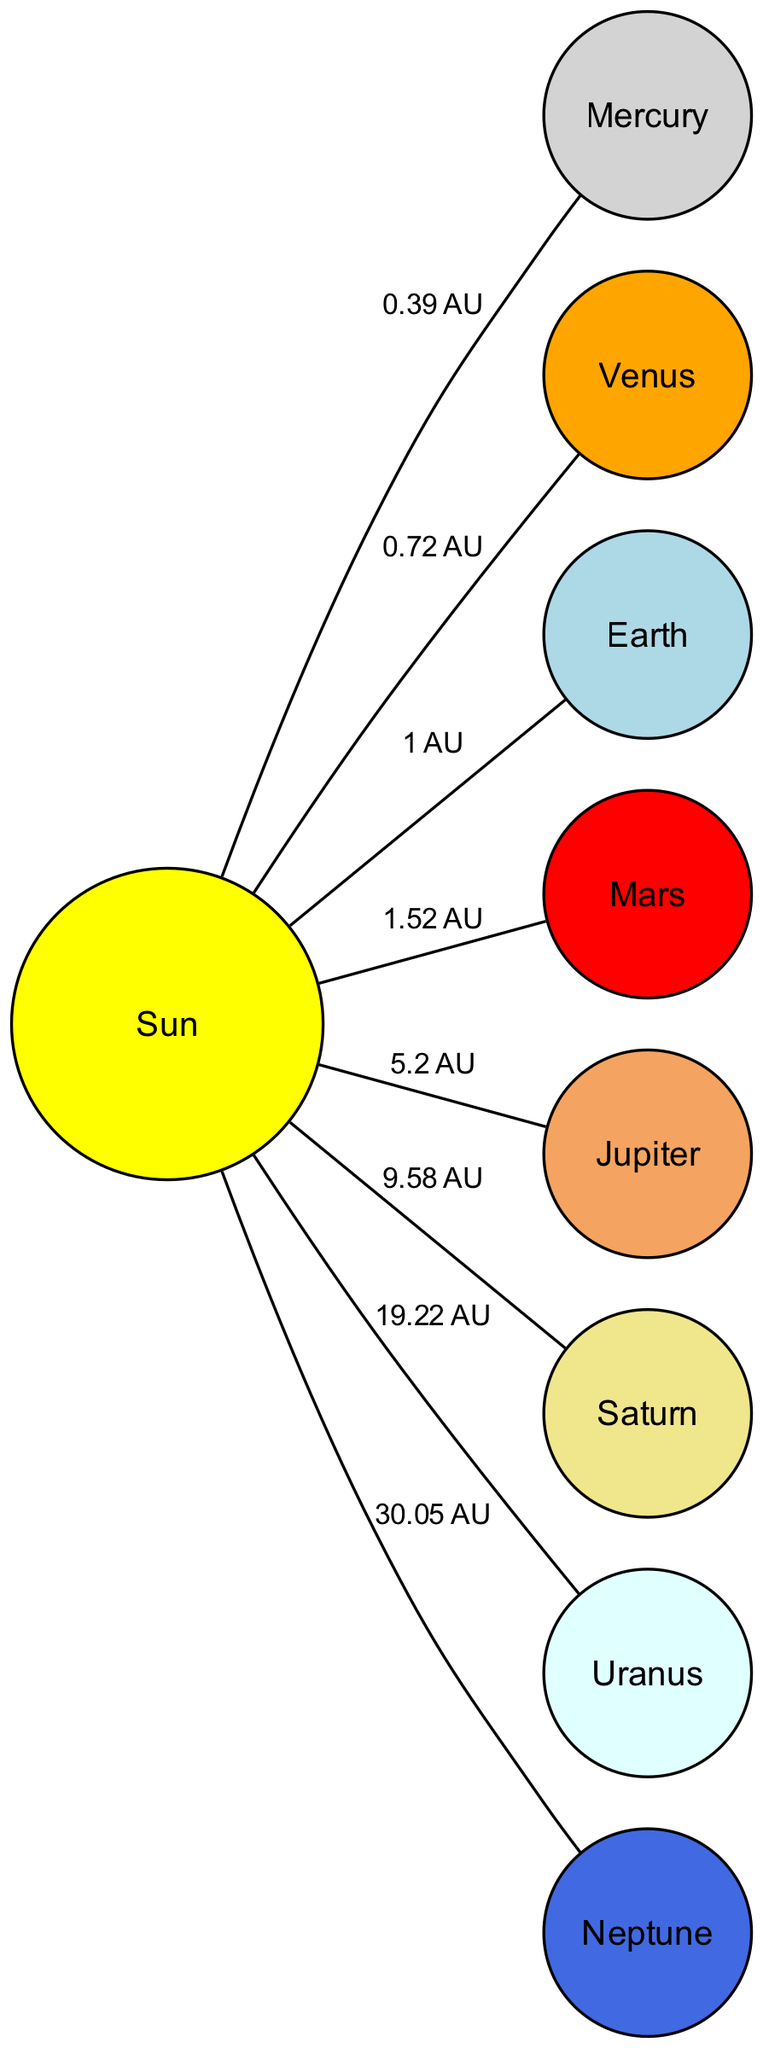What is the average distance of Mercury from the Sun? The diagram specifies that the average distance of Mercury from the Sun is labeled as "0.39 AU," where "AU" stands for Astronomical Units. This information can be easily found on the edge connecting Mercury to the Sun.
Answer: 0.39 AU Which planet is known as the Red Planet? According to the diagram, Mars is labeled as "The Red Planet." This descriptive label appears in the node that represents Mars.
Answer: Mars How many planets are shown in this diagram? The diagram lists a total of eight nodes, which represent the planets and the Sun. Counting these nodes reveals that there are seven planets along with the Sun, making it a total of eight.
Answer: 8 What is the average distance of Neptune from the Sun? The average distance of Neptune from the Sun is shown on the edge connecting Neptune to the Sun, labeled "30.05 AU." This value indicates the farthest distance from the Sun among all the planets.
Answer: 30.05 AU Which planet has the largest average distance from the Sun? By examining the distances specified for each planet, it is clear that Neptune, with an average distance of "30.05 AU," exceeds that of all other planets, making it the one with the largest distance from the Sun.
Answer: Neptune What color represents Saturn in the diagram? In the diagram, Saturn is illustrated with a khaki color. This color is indicated in the node representing Saturn, creating a distinction from the other planets.
Answer: khaki What is the average distance of Jupiter from the Sun compared to that of Earth? The average distance of Jupiter from the Sun is marked as "5.2 AU," while Earth's distance is "1 AU." This shows that Jupiter is significantly farther from the Sun than Earth since 5.2 is greater than 1.
Answer: 5.2 AU Which planet rotates on its side? The diagram highlights Uranus with a description noting that it "Rotates on its side." This special characteristic is indicated in the node for Uranus, providing unique identification.
Answer: Uranus Where does Venus fall in terms of its position from the Sun? According to the information presented, Venus is the second planet from the Sun, as cabled in the description within the node for Venus. This tells us its order in relation to the Sun.
Answer: Second planet from the Sun 